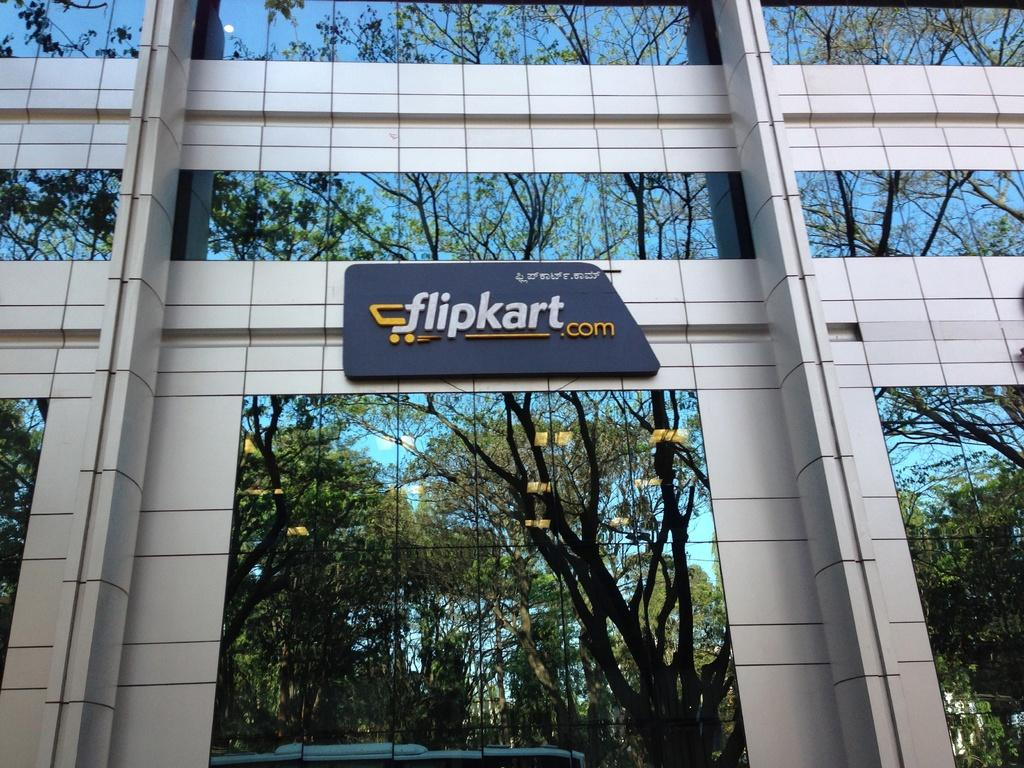What type of structure is present in the image? There is a building in the image. What feature can be observed on the building's exterior? The building has glass windows. Are there any architectural elements supporting the building? Yes, the building has pillars. Is there any signage on the building? There is a name board on the building. What can be seen in the reflection on the glass windows? The reflection of trees is visible on the glass windows. What type of loaf is being baked in the building's oven? There is no information about a loaf or an oven in the image, as it primarily focuses on the building's exterior features. 